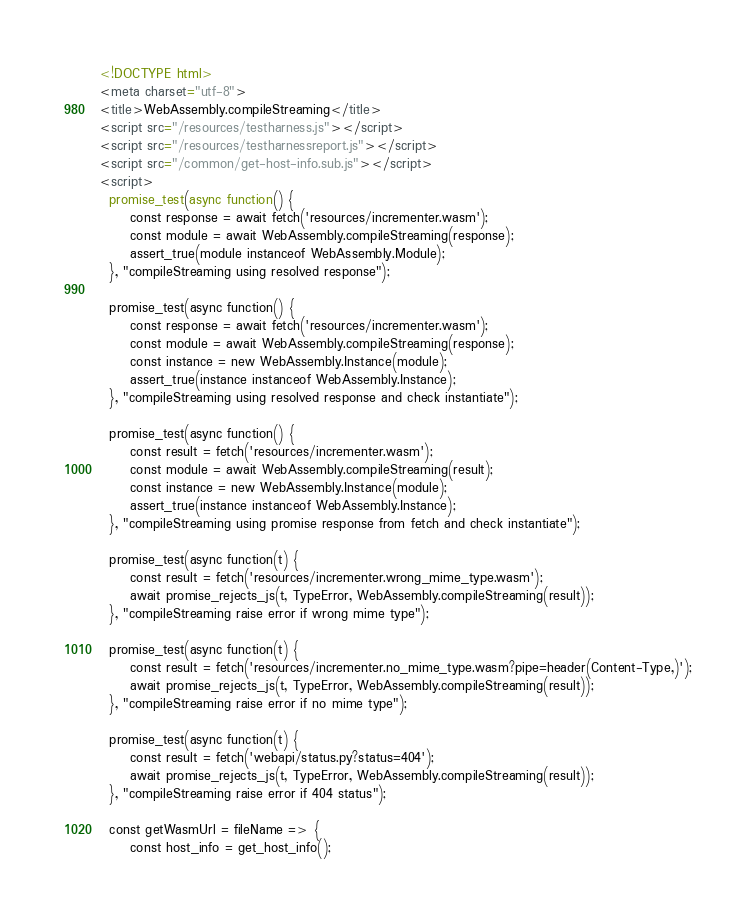Convert code to text. <code><loc_0><loc_0><loc_500><loc_500><_HTML_><!DOCTYPE html>
<meta charset="utf-8">
<title>WebAssembly.compileStreaming</title>
<script src="/resources/testharness.js"></script>
<script src="/resources/testharnessreport.js"></script>
<script src="/common/get-host-info.sub.js"></script>
<script>
  promise_test(async function() {
      const response = await fetch('resources/incrementer.wasm');
      const module = await WebAssembly.compileStreaming(response);
      assert_true(module instanceof WebAssembly.Module);
  }, "compileStreaming using resolved response");

  promise_test(async function() {
      const response = await fetch('resources/incrementer.wasm');
      const module = await WebAssembly.compileStreaming(response);
      const instance = new WebAssembly.Instance(module);
      assert_true(instance instanceof WebAssembly.Instance);
  }, "compileStreaming using resolved response and check instantiate");

  promise_test(async function() {
      const result = fetch('resources/incrementer.wasm');
      const module = await WebAssembly.compileStreaming(result);
      const instance = new WebAssembly.Instance(module);
      assert_true(instance instanceof WebAssembly.Instance);
  }, "compileStreaming using promise response from fetch and check instantiate");

  promise_test(async function(t) {
      const result = fetch('resources/incrementer.wrong_mime_type.wasm');
      await promise_rejects_js(t, TypeError, WebAssembly.compileStreaming(result));
  }, "compileStreaming raise error if wrong mime type");

  promise_test(async function(t) {
      const result = fetch('resources/incrementer.no_mime_type.wasm?pipe=header(Content-Type,)');
      await promise_rejects_js(t, TypeError, WebAssembly.compileStreaming(result));
  }, "compileStreaming raise error if no mime type");

  promise_test(async function(t) {
      const result = fetch('webapi/status.py?status=404');
      await promise_rejects_js(t, TypeError, WebAssembly.compileStreaming(result));
  }, "compileStreaming raise error if 404 status");

  const getWasmUrl = fileName => {
      const host_info = get_host_info();</code> 